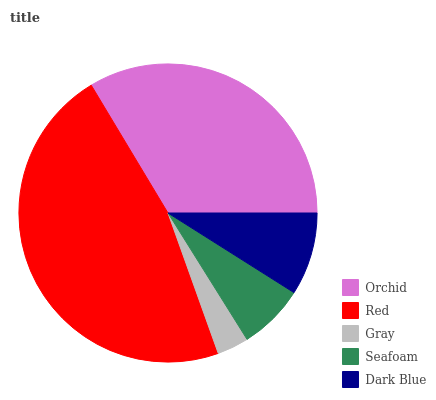Is Gray the minimum?
Answer yes or no. Yes. Is Red the maximum?
Answer yes or no. Yes. Is Red the minimum?
Answer yes or no. No. Is Gray the maximum?
Answer yes or no. No. Is Red greater than Gray?
Answer yes or no. Yes. Is Gray less than Red?
Answer yes or no. Yes. Is Gray greater than Red?
Answer yes or no. No. Is Red less than Gray?
Answer yes or no. No. Is Dark Blue the high median?
Answer yes or no. Yes. Is Dark Blue the low median?
Answer yes or no. Yes. Is Seafoam the high median?
Answer yes or no. No. Is Gray the low median?
Answer yes or no. No. 